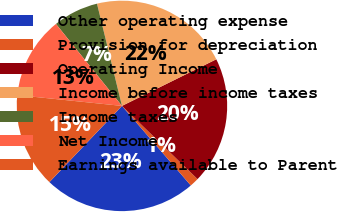Convert chart. <chart><loc_0><loc_0><loc_500><loc_500><pie_chart><fcel>Other operating expense<fcel>Provision for depreciation<fcel>Operating Income<fcel>Income before income taxes<fcel>Income taxes<fcel>Net Income<fcel>Earnings available to Parent<nl><fcel>23.46%<fcel>1.4%<fcel>19.55%<fcel>21.51%<fcel>6.98%<fcel>12.57%<fcel>14.53%<nl></chart> 